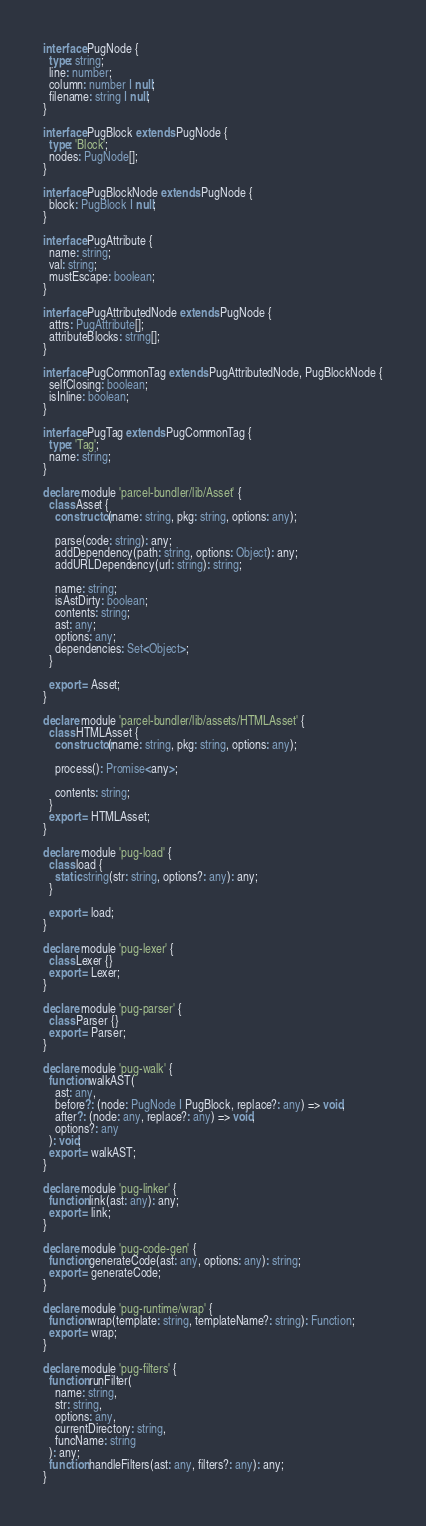Convert code to text. <code><loc_0><loc_0><loc_500><loc_500><_TypeScript_>interface PugNode {
  type: string;
  line: number;
  column: number | null;
  filename: string | null;
}

interface PugBlock extends PugNode {
  type: 'Block';
  nodes: PugNode[];
}

interface PugBlockNode extends PugNode {
  block: PugBlock | null;
}

interface PugAttribute {
  name: string;
  val: string;
  mustEscape: boolean;
}

interface PugAttributedNode extends PugNode {
  attrs: PugAttribute[];
  attributeBlocks: string[];
}

interface PugCommonTag extends PugAttributedNode, PugBlockNode {
  selfClosing: boolean;
  isInline: boolean;
}

interface PugTag extends PugCommonTag {
  type: 'Tag';
  name: string;
}

declare module 'parcel-bundler/lib/Asset' {
  class Asset {
    constructor(name: string, pkg: string, options: any);

    parse(code: string): any;
    addDependency(path: string, options: Object): any;
    addURLDependency(url: string): string;

    name: string;
    isAstDirty: boolean;
    contents: string;
    ast: any;
    options: any;
    dependencies: Set<Object>;
  }

  export = Asset;
}

declare module 'parcel-bundler/lib/assets/HTMLAsset' {
  class HTMLAsset {
    constructor(name: string, pkg: string, options: any);

    process(): Promise<any>;

    contents: string;
  }
  export = HTMLAsset;
}

declare module 'pug-load' {
  class load {
    static string(str: string, options?: any): any;
  }

  export = load;
}

declare module 'pug-lexer' {
  class Lexer {}
  export = Lexer;
}

declare module 'pug-parser' {
  class Parser {}
  export = Parser;
}

declare module 'pug-walk' {
  function walkAST(
    ast: any,
    before?: (node: PugNode | PugBlock, replace?: any) => void,
    after?: (node: any, replace?: any) => void,
    options?: any
  ): void;
  export = walkAST;
}

declare module 'pug-linker' {
  function link(ast: any): any;
  export = link;
}

declare module 'pug-code-gen' {
  function generateCode(ast: any, options: any): string;
  export = generateCode;
}

declare module 'pug-runtime/wrap' {
  function wrap(template: string, templateName?: string): Function;
  export = wrap;
}

declare module 'pug-filters' {
  function runFilter(
    name: string,
    str: string,
    options: any,
    currentDirectory: string,
    funcName: string
  ): any;
  function handleFilters(ast: any, filters?: any): any;
}
</code> 